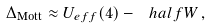<formula> <loc_0><loc_0><loc_500><loc_500>\Delta _ { \text {Mott} } \approx U _ { e f f } ( 4 ) - \ h a l f W \, ,</formula> 